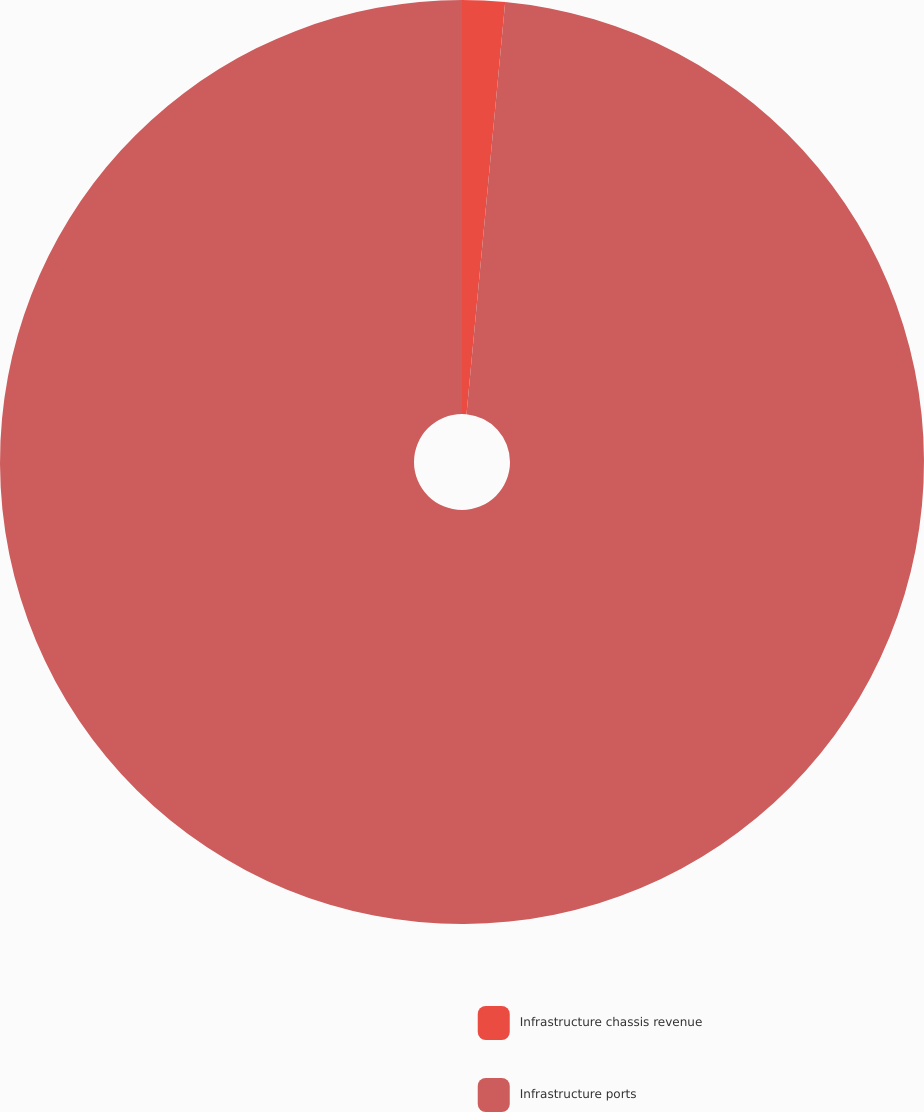Convert chart. <chart><loc_0><loc_0><loc_500><loc_500><pie_chart><fcel>Infrastructure chassis revenue<fcel>Infrastructure ports<nl><fcel>1.49%<fcel>98.51%<nl></chart> 